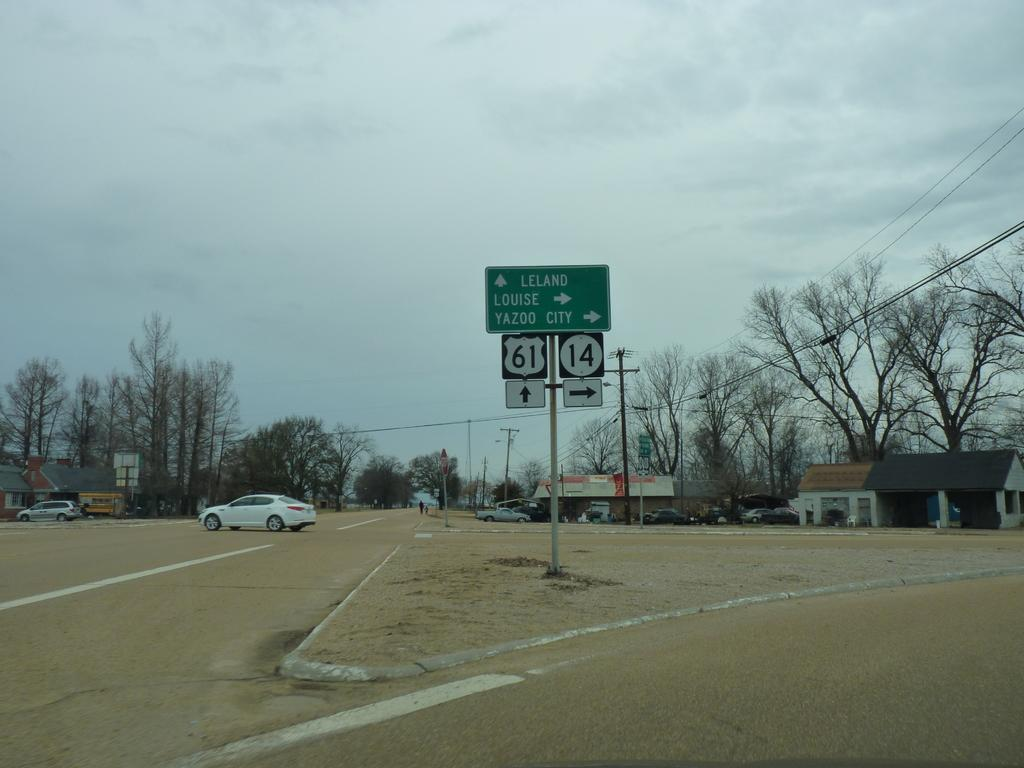<image>
Provide a brief description of the given image. Road signs that point to Leland, Louise, or Yazoo City. 